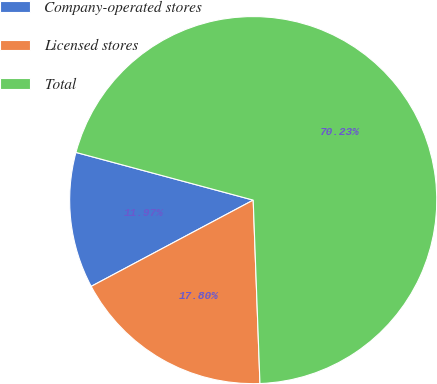<chart> <loc_0><loc_0><loc_500><loc_500><pie_chart><fcel>Company-operated stores<fcel>Licensed stores<fcel>Total<nl><fcel>11.97%<fcel>17.8%<fcel>70.23%<nl></chart> 